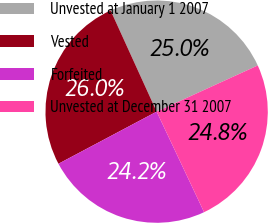<chart> <loc_0><loc_0><loc_500><loc_500><pie_chart><fcel>Unvested at January 1 2007<fcel>Vested<fcel>Forfeited<fcel>Unvested at December 31 2007<nl><fcel>24.98%<fcel>25.97%<fcel>24.25%<fcel>24.8%<nl></chart> 